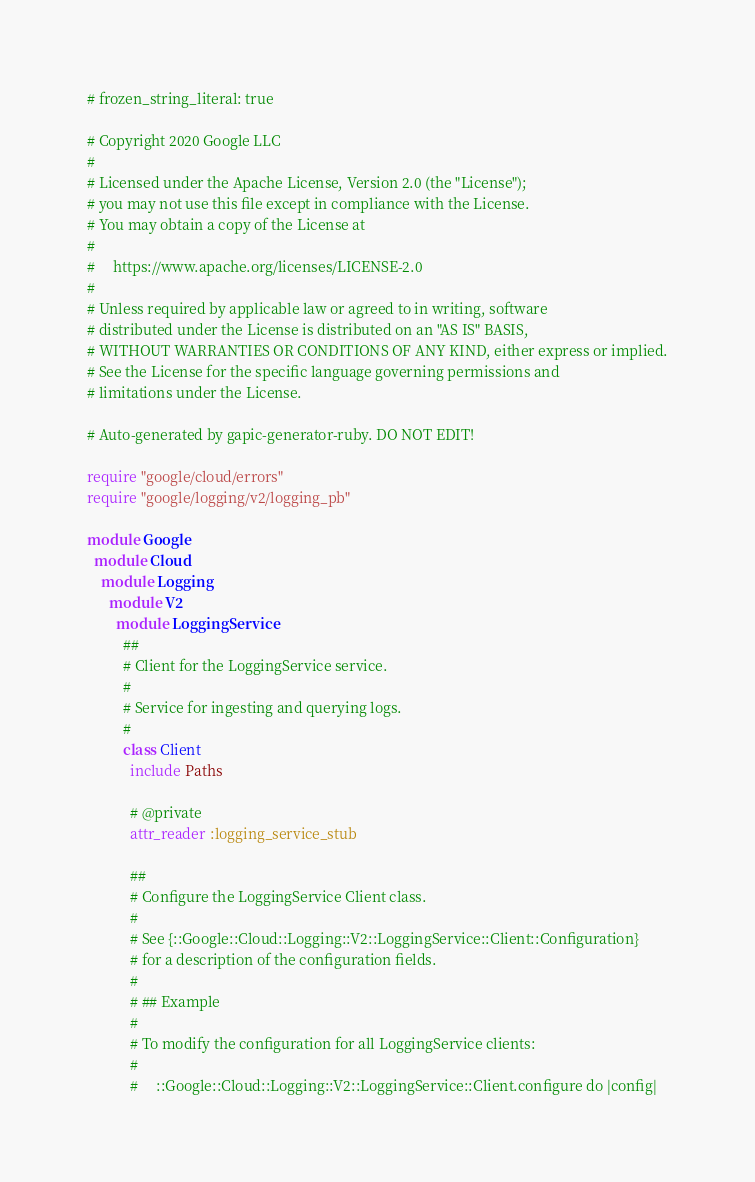Convert code to text. <code><loc_0><loc_0><loc_500><loc_500><_Ruby_># frozen_string_literal: true

# Copyright 2020 Google LLC
#
# Licensed under the Apache License, Version 2.0 (the "License");
# you may not use this file except in compliance with the License.
# You may obtain a copy of the License at
#
#     https://www.apache.org/licenses/LICENSE-2.0
#
# Unless required by applicable law or agreed to in writing, software
# distributed under the License is distributed on an "AS IS" BASIS,
# WITHOUT WARRANTIES OR CONDITIONS OF ANY KIND, either express or implied.
# See the License for the specific language governing permissions and
# limitations under the License.

# Auto-generated by gapic-generator-ruby. DO NOT EDIT!

require "google/cloud/errors"
require "google/logging/v2/logging_pb"

module Google
  module Cloud
    module Logging
      module V2
        module LoggingService
          ##
          # Client for the LoggingService service.
          #
          # Service for ingesting and querying logs.
          #
          class Client
            include Paths

            # @private
            attr_reader :logging_service_stub

            ##
            # Configure the LoggingService Client class.
            #
            # See {::Google::Cloud::Logging::V2::LoggingService::Client::Configuration}
            # for a description of the configuration fields.
            #
            # ## Example
            #
            # To modify the configuration for all LoggingService clients:
            #
            #     ::Google::Cloud::Logging::V2::LoggingService::Client.configure do |config|</code> 